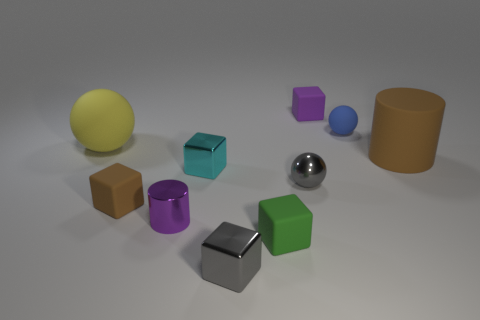What number of purple matte objects are there?
Your answer should be compact. 1. Is the material of the large brown thing the same as the tiny block behind the brown matte cylinder?
Offer a terse response. Yes. There is a tiny matte thing on the right side of the small purple matte cube; is its color the same as the big rubber cylinder?
Give a very brief answer. No. The ball that is both right of the big yellow matte object and behind the large cylinder is made of what material?
Provide a short and direct response. Rubber. What size is the gray shiny cube?
Your answer should be very brief. Small. There is a large ball; is it the same color as the large rubber thing right of the yellow thing?
Keep it short and to the point. No. How many other objects are there of the same color as the tiny cylinder?
Ensure brevity in your answer.  1. Is the size of the sphere left of the green object the same as the green object that is in front of the small brown rubber object?
Give a very brief answer. No. What is the color of the ball that is to the left of the tiny brown matte object?
Ensure brevity in your answer.  Yellow. Are there fewer purple cubes to the right of the tiny blue rubber ball than small brown matte objects?
Make the answer very short. Yes. 